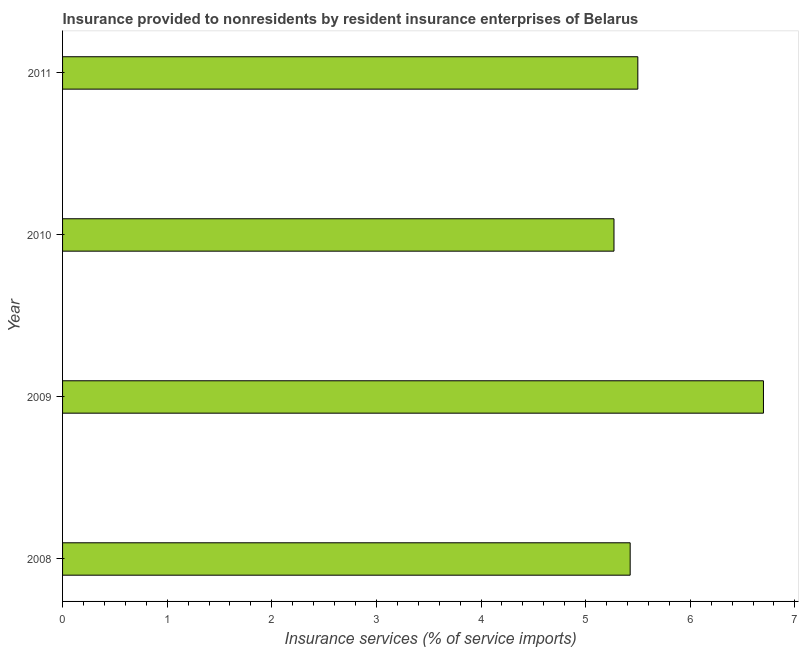What is the title of the graph?
Provide a succinct answer. Insurance provided to nonresidents by resident insurance enterprises of Belarus. What is the label or title of the X-axis?
Your answer should be compact. Insurance services (% of service imports). What is the label or title of the Y-axis?
Provide a succinct answer. Year. What is the insurance and financial services in 2009?
Keep it short and to the point. 6.7. Across all years, what is the maximum insurance and financial services?
Provide a succinct answer. 6.7. Across all years, what is the minimum insurance and financial services?
Keep it short and to the point. 5.27. What is the sum of the insurance and financial services?
Provide a succinct answer. 22.9. What is the difference between the insurance and financial services in 2010 and 2011?
Offer a very short reply. -0.23. What is the average insurance and financial services per year?
Offer a terse response. 5.72. What is the median insurance and financial services?
Make the answer very short. 5.46. In how many years, is the insurance and financial services greater than 4.4 %?
Offer a very short reply. 4. What is the ratio of the insurance and financial services in 2008 to that in 2011?
Ensure brevity in your answer.  0.99. Is the insurance and financial services in 2009 less than that in 2010?
Give a very brief answer. No. Is the difference between the insurance and financial services in 2008 and 2011 greater than the difference between any two years?
Keep it short and to the point. No. What is the difference between the highest and the second highest insurance and financial services?
Your response must be concise. 1.2. What is the difference between the highest and the lowest insurance and financial services?
Keep it short and to the point. 1.43. Are all the bars in the graph horizontal?
Offer a very short reply. Yes. How many years are there in the graph?
Provide a short and direct response. 4. What is the difference between two consecutive major ticks on the X-axis?
Make the answer very short. 1. What is the Insurance services (% of service imports) in 2008?
Offer a very short reply. 5.43. What is the Insurance services (% of service imports) in 2009?
Keep it short and to the point. 6.7. What is the Insurance services (% of service imports) in 2010?
Offer a very short reply. 5.27. What is the Insurance services (% of service imports) of 2011?
Give a very brief answer. 5.5. What is the difference between the Insurance services (% of service imports) in 2008 and 2009?
Your response must be concise. -1.27. What is the difference between the Insurance services (% of service imports) in 2008 and 2010?
Your answer should be compact. 0.15. What is the difference between the Insurance services (% of service imports) in 2008 and 2011?
Your answer should be compact. -0.07. What is the difference between the Insurance services (% of service imports) in 2009 and 2010?
Offer a very short reply. 1.43. What is the difference between the Insurance services (% of service imports) in 2009 and 2011?
Your answer should be compact. 1.2. What is the difference between the Insurance services (% of service imports) in 2010 and 2011?
Provide a succinct answer. -0.23. What is the ratio of the Insurance services (% of service imports) in 2008 to that in 2009?
Give a very brief answer. 0.81. What is the ratio of the Insurance services (% of service imports) in 2008 to that in 2011?
Ensure brevity in your answer.  0.99. What is the ratio of the Insurance services (% of service imports) in 2009 to that in 2010?
Your answer should be very brief. 1.27. What is the ratio of the Insurance services (% of service imports) in 2009 to that in 2011?
Provide a short and direct response. 1.22. What is the ratio of the Insurance services (% of service imports) in 2010 to that in 2011?
Offer a terse response. 0.96. 